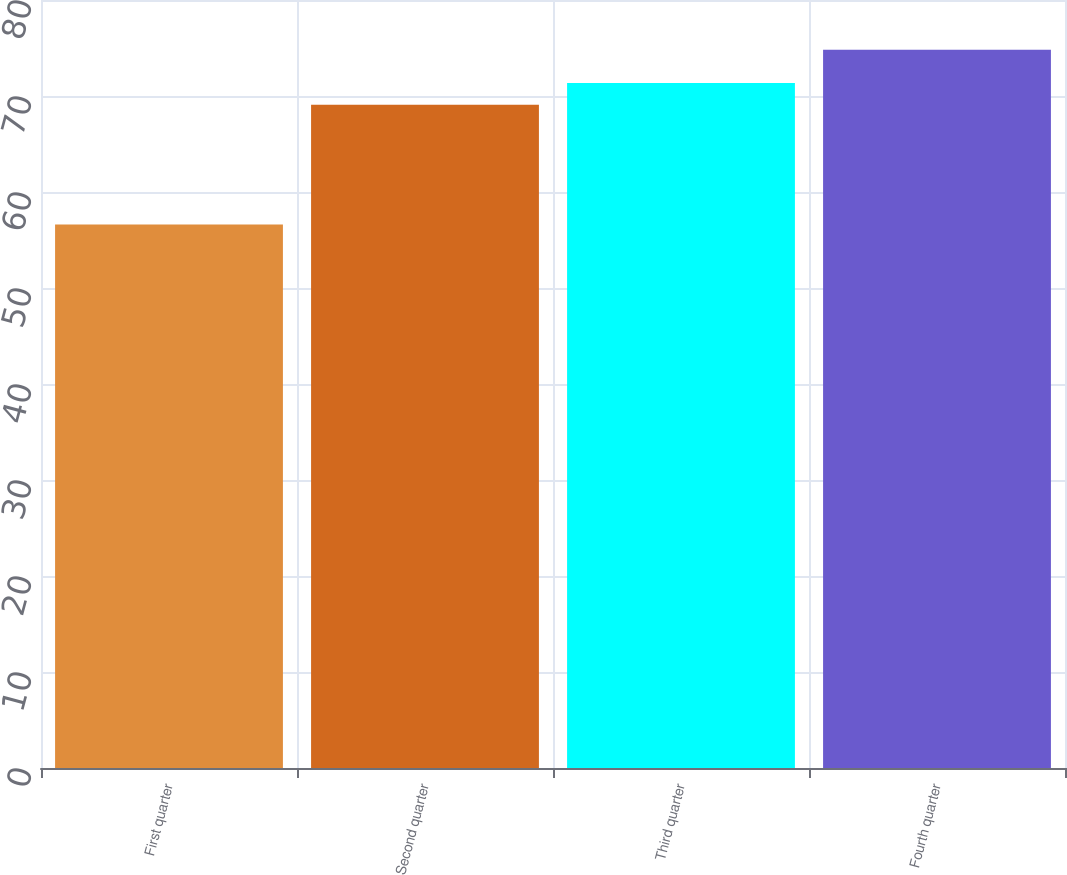Convert chart to OTSL. <chart><loc_0><loc_0><loc_500><loc_500><bar_chart><fcel>First quarter<fcel>Second quarter<fcel>Third quarter<fcel>Fourth quarter<nl><fcel>56.61<fcel>69.09<fcel>71.35<fcel>74.81<nl></chart> 